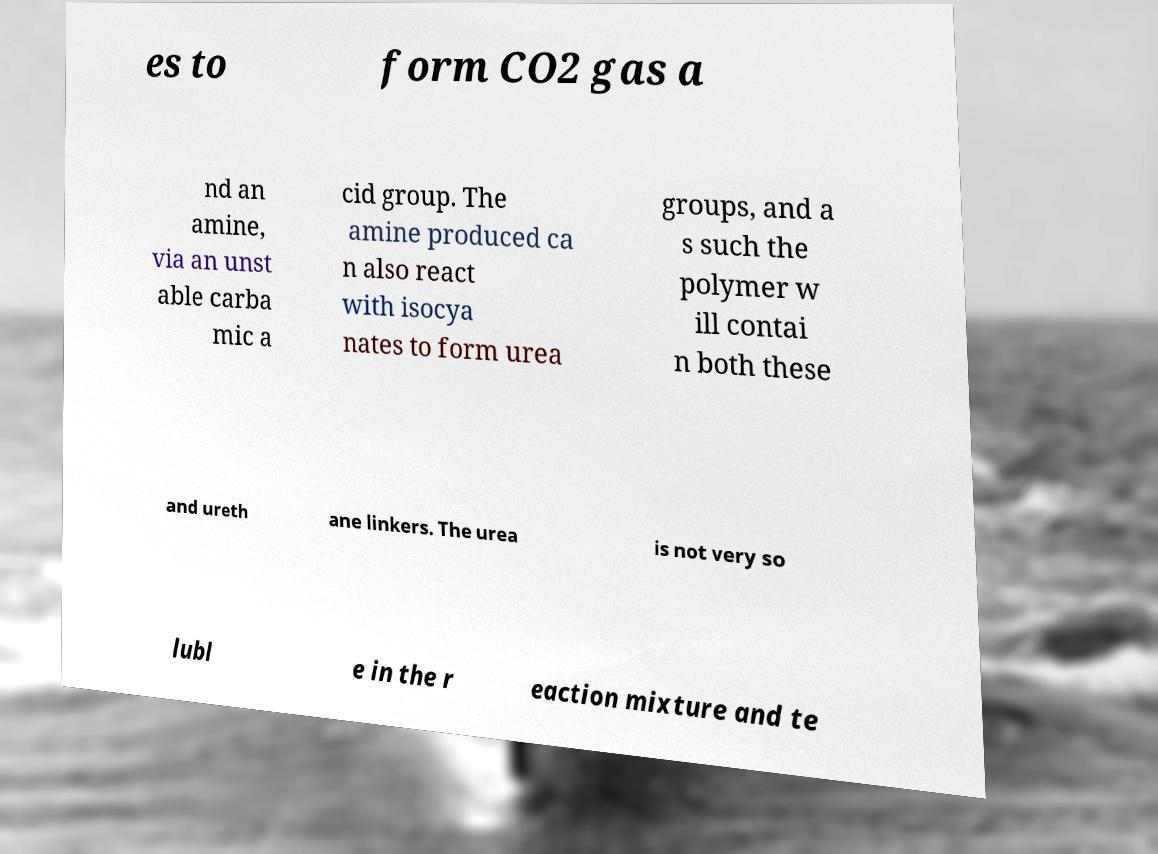Could you assist in decoding the text presented in this image and type it out clearly? es to form CO2 gas a nd an amine, via an unst able carba mic a cid group. The amine produced ca n also react with isocya nates to form urea groups, and a s such the polymer w ill contai n both these and ureth ane linkers. The urea is not very so lubl e in the r eaction mixture and te 